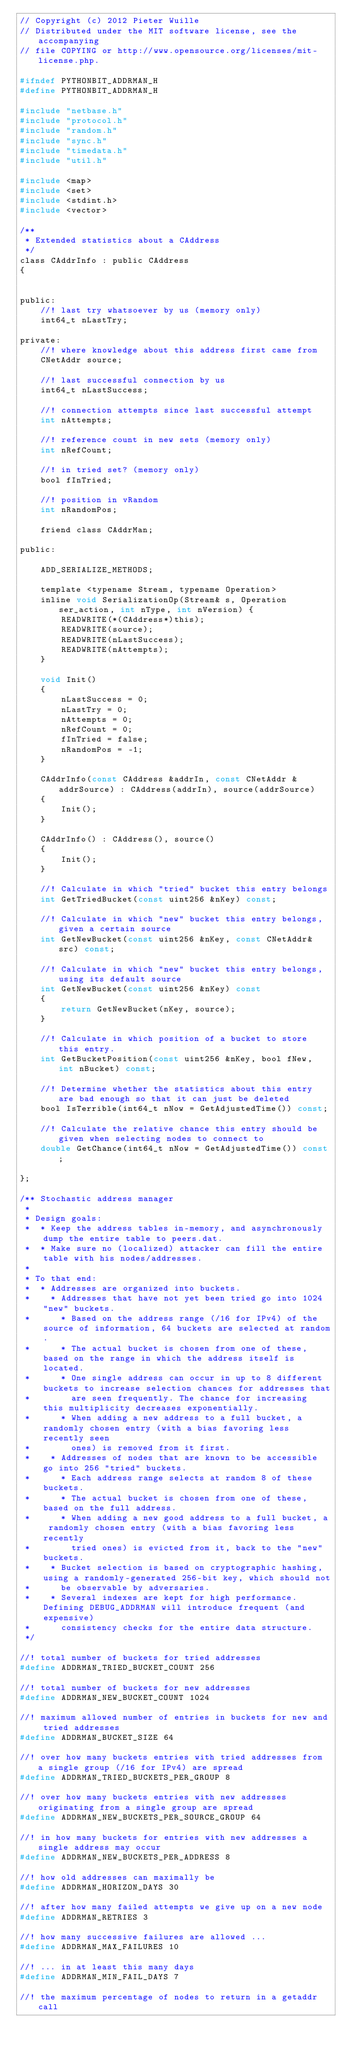Convert code to text. <code><loc_0><loc_0><loc_500><loc_500><_C_>// Copyright (c) 2012 Pieter Wuille
// Distributed under the MIT software license, see the accompanying
// file COPYING or http://www.opensource.org/licenses/mit-license.php.

#ifndef PYTHONBIT_ADDRMAN_H
#define PYTHONBIT_ADDRMAN_H

#include "netbase.h"
#include "protocol.h"
#include "random.h"
#include "sync.h"
#include "timedata.h"
#include "util.h"

#include <map>
#include <set>
#include <stdint.h>
#include <vector>

/**
 * Extended statistics about a CAddress
 */
class CAddrInfo : public CAddress
{


public:
    //! last try whatsoever by us (memory only)
    int64_t nLastTry;

private:
    //! where knowledge about this address first came from
    CNetAddr source;

    //! last successful connection by us
    int64_t nLastSuccess;

    //! connection attempts since last successful attempt
    int nAttempts;

    //! reference count in new sets (memory only)
    int nRefCount;

    //! in tried set? (memory only)
    bool fInTried;

    //! position in vRandom
    int nRandomPos;

    friend class CAddrMan;

public:

    ADD_SERIALIZE_METHODS;

    template <typename Stream, typename Operation>
    inline void SerializationOp(Stream& s, Operation ser_action, int nType, int nVersion) {
        READWRITE(*(CAddress*)this);
        READWRITE(source);
        READWRITE(nLastSuccess);
        READWRITE(nAttempts);
    }

    void Init()
    {
        nLastSuccess = 0;
        nLastTry = 0;
        nAttempts = 0;
        nRefCount = 0;
        fInTried = false;
        nRandomPos = -1;
    }

    CAddrInfo(const CAddress &addrIn, const CNetAddr &addrSource) : CAddress(addrIn), source(addrSource)
    {
        Init();
    }

    CAddrInfo() : CAddress(), source()
    {
        Init();
    }

    //! Calculate in which "tried" bucket this entry belongs
    int GetTriedBucket(const uint256 &nKey) const;

    //! Calculate in which "new" bucket this entry belongs, given a certain source
    int GetNewBucket(const uint256 &nKey, const CNetAddr& src) const;

    //! Calculate in which "new" bucket this entry belongs, using its default source
    int GetNewBucket(const uint256 &nKey) const
    {
        return GetNewBucket(nKey, source);
    }

    //! Calculate in which position of a bucket to store this entry.
    int GetBucketPosition(const uint256 &nKey, bool fNew, int nBucket) const;

    //! Determine whether the statistics about this entry are bad enough so that it can just be deleted
    bool IsTerrible(int64_t nNow = GetAdjustedTime()) const;

    //! Calculate the relative chance this entry should be given when selecting nodes to connect to
    double GetChance(int64_t nNow = GetAdjustedTime()) const;

};

/** Stochastic address manager
 *
 * Design goals:
 *  * Keep the address tables in-memory, and asynchronously dump the entire table to peers.dat.
 *  * Make sure no (localized) attacker can fill the entire table with his nodes/addresses.
 *
 * To that end:
 *  * Addresses are organized into buckets.
 *    * Addresses that have not yet been tried go into 1024 "new" buckets.
 *      * Based on the address range (/16 for IPv4) of the source of information, 64 buckets are selected at random.
 *      * The actual bucket is chosen from one of these, based on the range in which the address itself is located.
 *      * One single address can occur in up to 8 different buckets to increase selection chances for addresses that
 *        are seen frequently. The chance for increasing this multiplicity decreases exponentially.
 *      * When adding a new address to a full bucket, a randomly chosen entry (with a bias favoring less recently seen
 *        ones) is removed from it first.
 *    * Addresses of nodes that are known to be accessible go into 256 "tried" buckets.
 *      * Each address range selects at random 8 of these buckets.
 *      * The actual bucket is chosen from one of these, based on the full address.
 *      * When adding a new good address to a full bucket, a randomly chosen entry (with a bias favoring less recently
 *        tried ones) is evicted from it, back to the "new" buckets.
 *    * Bucket selection is based on cryptographic hashing, using a randomly-generated 256-bit key, which should not
 *      be observable by adversaries.
 *    * Several indexes are kept for high performance. Defining DEBUG_ADDRMAN will introduce frequent (and expensive)
 *      consistency checks for the entire data structure.
 */

//! total number of buckets for tried addresses
#define ADDRMAN_TRIED_BUCKET_COUNT 256

//! total number of buckets for new addresses
#define ADDRMAN_NEW_BUCKET_COUNT 1024

//! maximum allowed number of entries in buckets for new and tried addresses
#define ADDRMAN_BUCKET_SIZE 64

//! over how many buckets entries with tried addresses from a single group (/16 for IPv4) are spread
#define ADDRMAN_TRIED_BUCKETS_PER_GROUP 8

//! over how many buckets entries with new addresses originating from a single group are spread
#define ADDRMAN_NEW_BUCKETS_PER_SOURCE_GROUP 64

//! in how many buckets for entries with new addresses a single address may occur
#define ADDRMAN_NEW_BUCKETS_PER_ADDRESS 8

//! how old addresses can maximally be
#define ADDRMAN_HORIZON_DAYS 30

//! after how many failed attempts we give up on a new node
#define ADDRMAN_RETRIES 3

//! how many successive failures are allowed ...
#define ADDRMAN_MAX_FAILURES 10

//! ... in at least this many days
#define ADDRMAN_MIN_FAIL_DAYS 7

//! the maximum percentage of nodes to return in a getaddr call</code> 